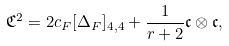Convert formula to latex. <formula><loc_0><loc_0><loc_500><loc_500>\mathfrak { C } ^ { 2 } = 2 c _ { F } [ \Delta _ { F } ] _ { 4 , 4 } + \frac { 1 } { r + 2 } \mathfrak { c } \otimes \mathfrak { c } ,</formula> 